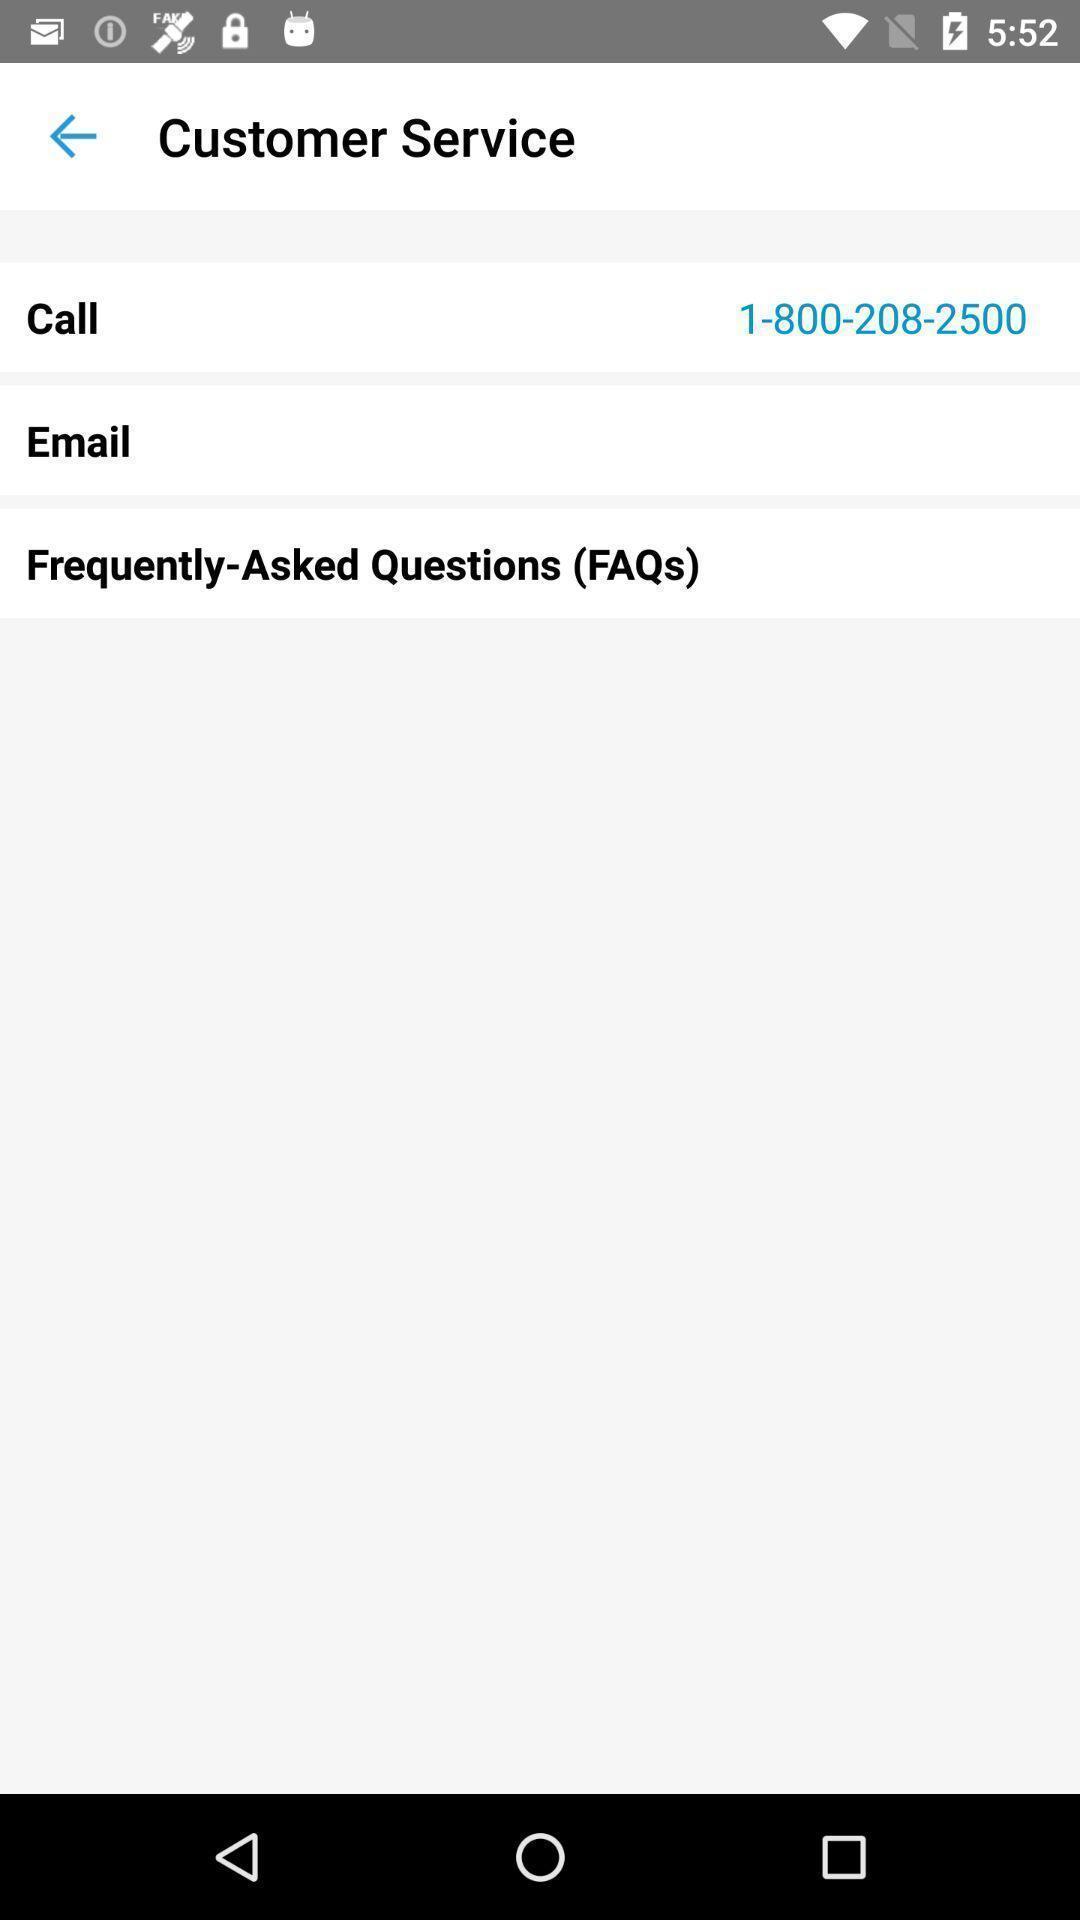What details can you identify in this image? Screen display customer service page. 